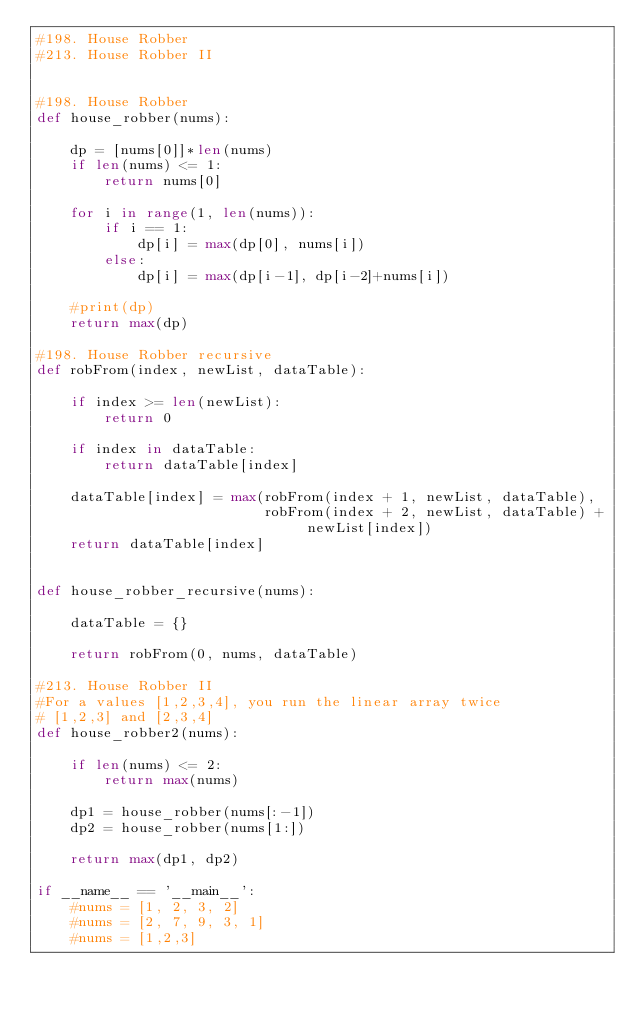<code> <loc_0><loc_0><loc_500><loc_500><_Python_>#198. House Robber
#213. House Robber II


#198. House Robber
def house_robber(nums):

    dp = [nums[0]]*len(nums)
    if len(nums) <= 1:
        return nums[0]

    for i in range(1, len(nums)):
        if i == 1:
            dp[i] = max(dp[0], nums[i])
        else:
            dp[i] = max(dp[i-1], dp[i-2]+nums[i])

    #print(dp)
    return max(dp)

#198. House Robber recursive
def robFrom(index, newList, dataTable):

    if index >= len(newList):
        return 0

    if index in dataTable:
        return dataTable[index]

    dataTable[index] = max(robFrom(index + 1, newList, dataTable),
                           robFrom(index + 2, newList, dataTable) + newList[index])
    return dataTable[index]


def house_robber_recursive(nums):

    dataTable = {}

    return robFrom(0, nums, dataTable)

#213. House Robber II
#For a values [1,2,3,4], you run the linear array twice
# [1,2,3] and [2,3,4]
def house_robber2(nums):

    if len(nums) <= 2:
        return max(nums)

    dp1 = house_robber(nums[:-1])
    dp2 = house_robber(nums[1:])

    return max(dp1, dp2)

if __name__ == '__main__':
    #nums = [1, 2, 3, 2]
    #nums = [2, 7, 9, 3, 1]
    #nums = [1,2,3]</code> 